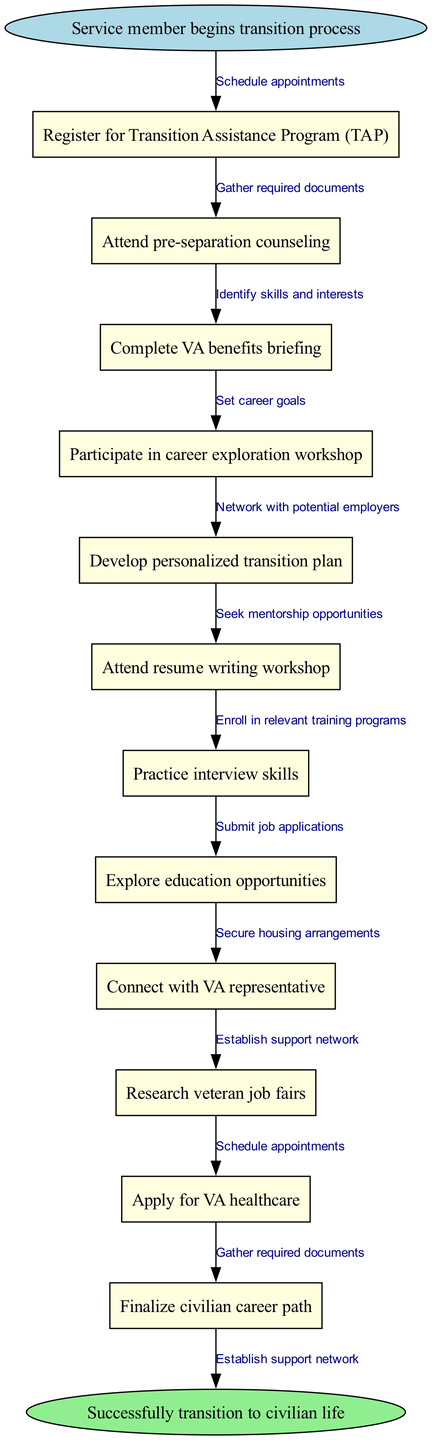What is the first step in the transition process? The first step in the transition process, as indicated in the diagram, is represented by the start node, which is "Service member begins transition process."
Answer: Service member begins transition process How many nodes are in the diagram? To determine the number of nodes, we count the individual steps included in the transition process, which are ten nodes listed.
Answer: 10 What is the end goal of this flowchart? The end goal, as indicated in the end node of the diagram, is to successfully transition to civilian life.
Answer: Successfully transition to civilian life What node follows the 'Complete VA benefits briefing'? The flowchart shows that after the 'Complete VA benefits briefing,' the next node is 'Participate in career exploration workshop.'
Answer: Participate in career exploration workshop How many edges connect the nodes in this flowchart? The number of edges can be calculated based on the connections between nodes, with each step leading to the next and a final connection to the end node, totaling ten edges.
Answer: 10 Which node is connected to 'Research veteran job fairs'? In the sequence of nodes, 'Research veteran job fairs' is connected to 'Submit job applications' as the following step in the process.
Answer: Submit job applications What is the relationship between 'Attend resume writing workshop' and 'Practice interview skills'? The relationship is that both nodes are sequential steps in the career counseling process, as 'Attend resume writing workshop' leads directly to 'Practice interview skills.'
Answer: Sequential steps What does the 'Gather required documents' edge connect? The 'Gather required documents' edge connects the 'Register for Transition Assistance Program (TAP)' node to its next step, indicating preparation for the transition process.
Answer: Register for Transition Assistance Program (TAP) What is the last node before the end of the flowchart? The last node before the end of the flowchart is 'Finalize civilian career path,' which indicates the final step before achieving the end goal.
Answer: Finalize civilian career path 